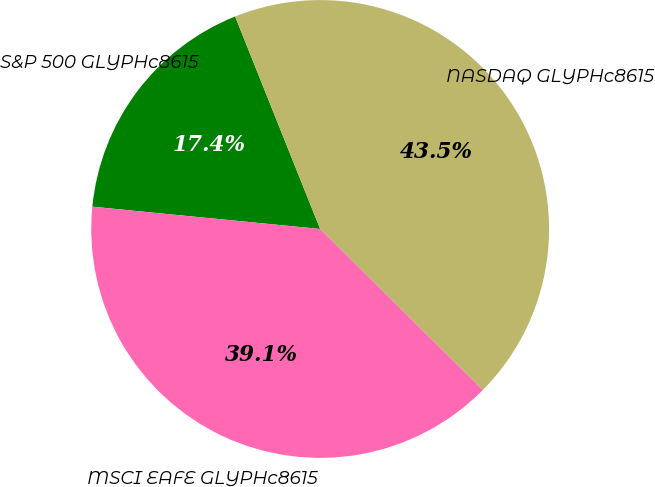Convert chart to OTSL. <chart><loc_0><loc_0><loc_500><loc_500><pie_chart><fcel>S&P 500 GLYPHc8615<fcel>NASDAQ GLYPHc8615<fcel>MSCI EAFE GLYPHc8615<nl><fcel>17.39%<fcel>43.48%<fcel>39.13%<nl></chart> 